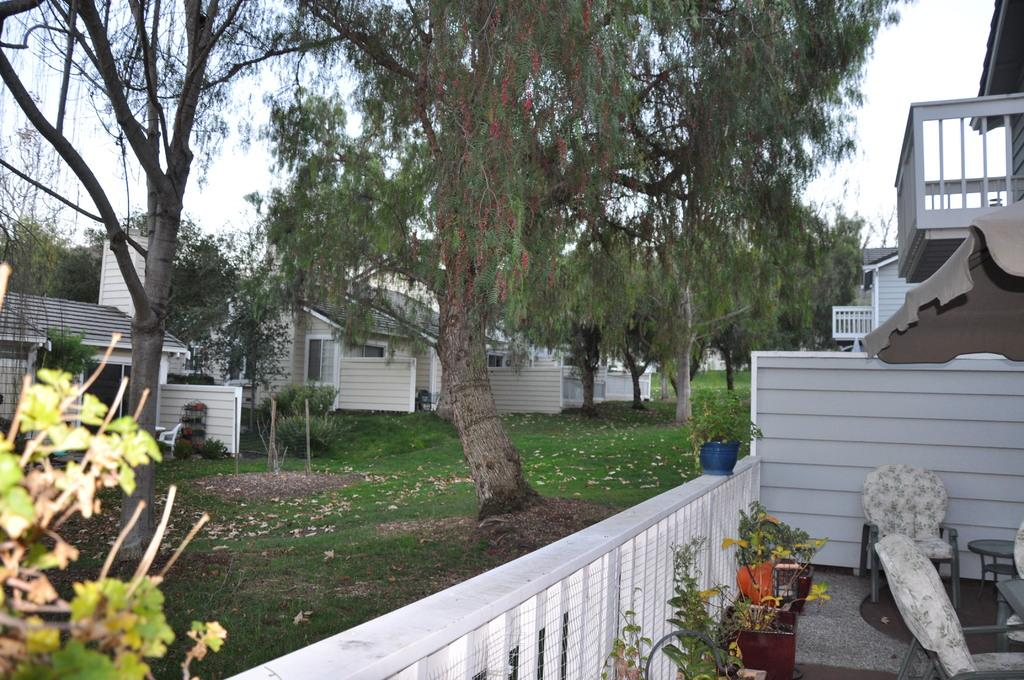What type of structures can be seen in the image? There are buildings in the image. What type of vegetation is present in the image? There are trees and plants with flower pots in the image. What type of furniture is visible in the image? There are chairs and tables in the image. What can be seen in the background of the image? The sky is visible in the background of the image. Where is the bomb located in the image? There is no bomb present in the image. Can you describe the island in the image? There is no island present in the image. 